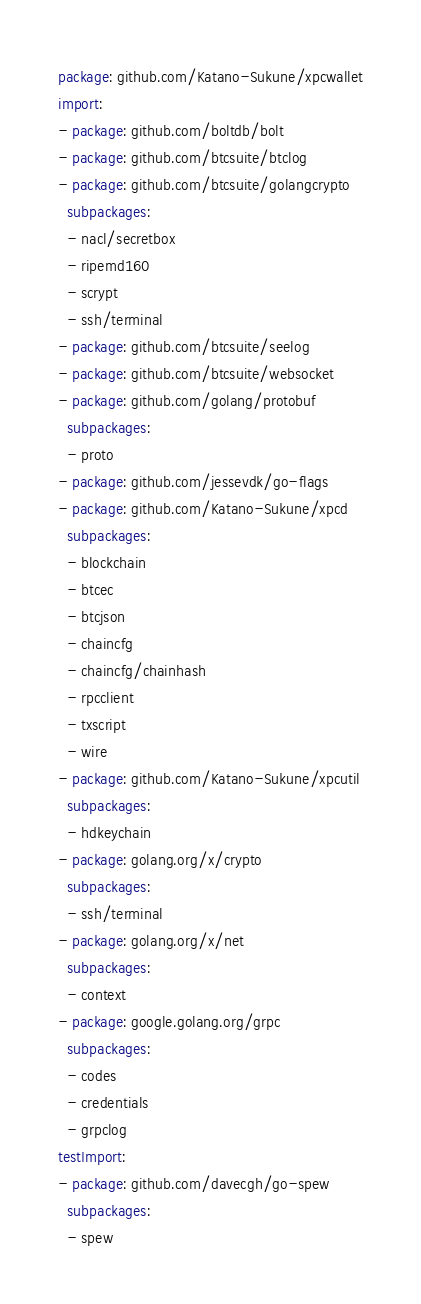Convert code to text. <code><loc_0><loc_0><loc_500><loc_500><_YAML_>package: github.com/Katano-Sukune/xpcwallet
import:
- package: github.com/boltdb/bolt
- package: github.com/btcsuite/btclog
- package: github.com/btcsuite/golangcrypto
  subpackages:
  - nacl/secretbox
  - ripemd160
  - scrypt
  - ssh/terminal
- package: github.com/btcsuite/seelog
- package: github.com/btcsuite/websocket
- package: github.com/golang/protobuf
  subpackages:
  - proto
- package: github.com/jessevdk/go-flags
- package: github.com/Katano-Sukune/xpcd
  subpackages:
  - blockchain
  - btcec
  - btcjson
  - chaincfg
  - chaincfg/chainhash
  - rpcclient
  - txscript
  - wire
- package: github.com/Katano-Sukune/xpcutil
  subpackages:
  - hdkeychain
- package: golang.org/x/crypto
  subpackages:
  - ssh/terminal
- package: golang.org/x/net
  subpackages:
  - context
- package: google.golang.org/grpc
  subpackages:
  - codes
  - credentials
  - grpclog
testImport:
- package: github.com/davecgh/go-spew
  subpackages:
  - spew
</code> 